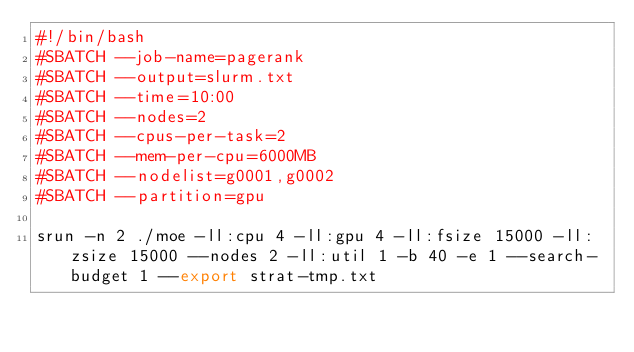<code> <loc_0><loc_0><loc_500><loc_500><_Bash_>#!/bin/bash
#SBATCH --job-name=pagerank
#SBATCH --output=slurm.txt
#SBATCH --time=10:00
#SBATCH --nodes=2
#SBATCH --cpus-per-task=2
#SBATCH --mem-per-cpu=6000MB
#SBATCH --nodelist=g0001,g0002
#SBATCH --partition=gpu

srun -n 2 ./moe -ll:cpu 4 -ll:gpu 4 -ll:fsize 15000 -ll:zsize 15000 --nodes 2 -ll:util 1 -b 40 -e 1 --search-budget 1 --export strat-tmp.txt
</code> 